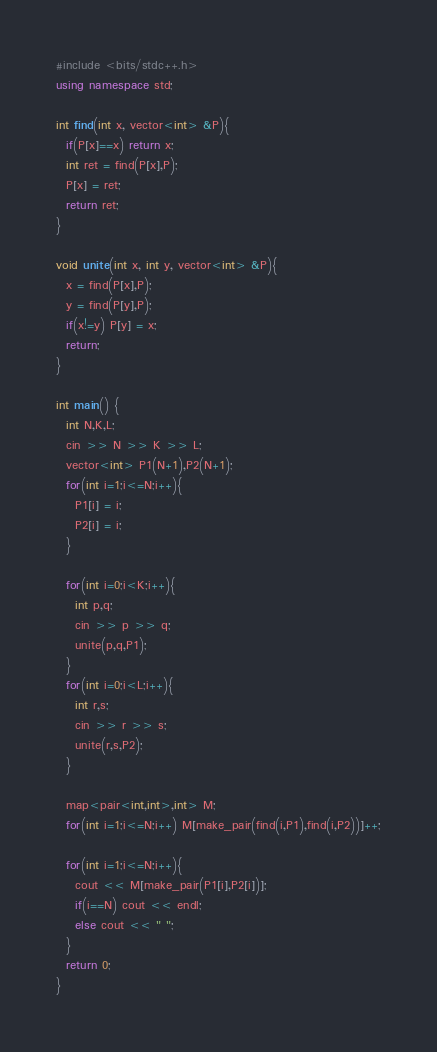Convert code to text. <code><loc_0><loc_0><loc_500><loc_500><_C++_>#include <bits/stdc++.h>
using namespace std;

int find(int x, vector<int> &P){
  if(P[x]==x) return x;
  int ret = find(P[x],P);
  P[x] = ret;
  return ret;
}

void unite(int x, int y, vector<int> &P){
  x = find(P[x],P);
  y = find(P[y],P);
  if(x!=y) P[y] = x;
  return;
}

int main() {
  int N,K,L;
  cin >> N >> K >> L;
  vector<int> P1(N+1),P2(N+1);
  for(int i=1;i<=N;i++){
    P1[i] = i;
    P2[i] = i;
  }
  
  for(int i=0;i<K;i++){
    int p,q;
    cin >> p >> q;
    unite(p,q,P1);
  }
  for(int i=0;i<L;i++){
    int r,s;
    cin >> r >> s;
    unite(r,s,P2);
  }
  
  map<pair<int,int>,int> M;
  for(int i=1;i<=N;i++) M[make_pair(find(i,P1),find(i,P2))]++;
  
  for(int i=1;i<=N;i++){
    cout << M[make_pair(P1[i],P2[i])];
    if(i==N) cout << endl;
    else cout << " ";
  }
  return 0;
}
</code> 